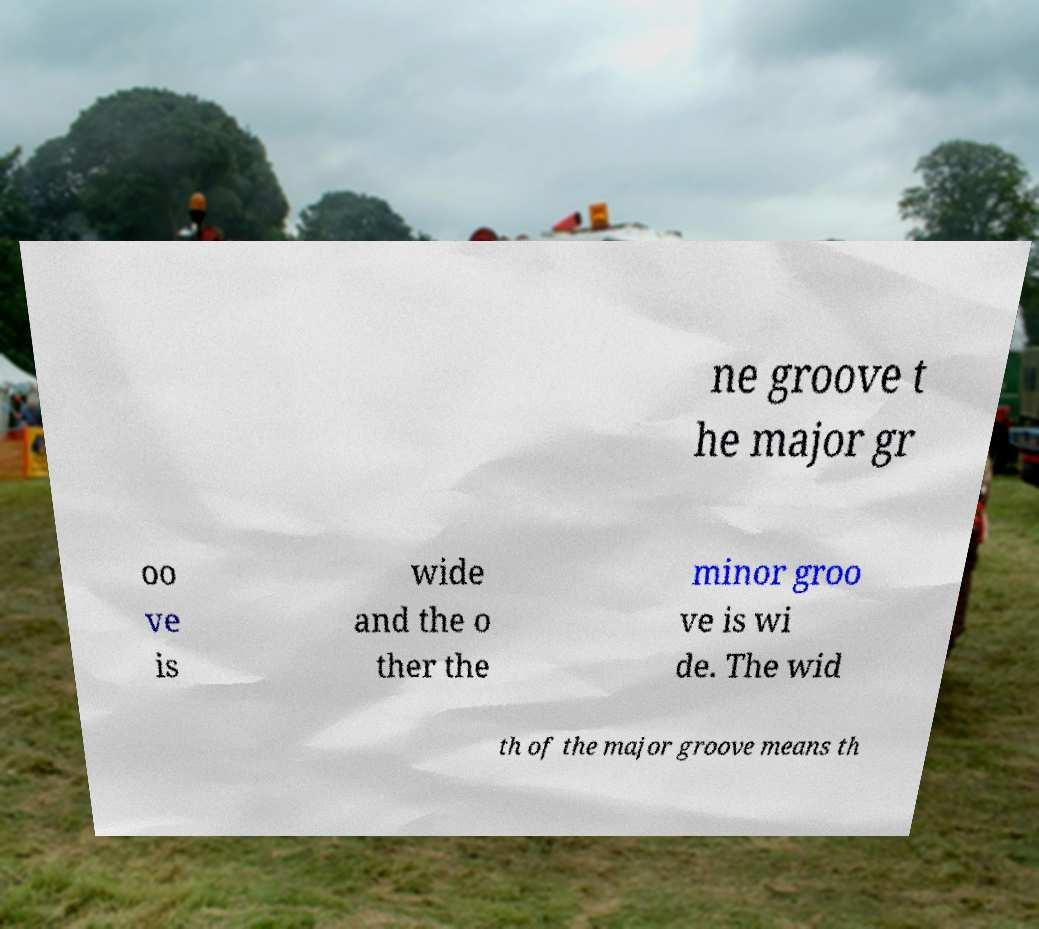Please read and relay the text visible in this image. What does it say? ne groove t he major gr oo ve is wide and the o ther the minor groo ve is wi de. The wid th of the major groove means th 